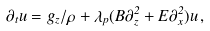Convert formula to latex. <formula><loc_0><loc_0><loc_500><loc_500>\partial _ { t } u = g _ { z } / \rho + \lambda _ { p } ( B \partial _ { z } ^ { 2 } + E \partial _ { x } ^ { 2 } ) u \, ,</formula> 